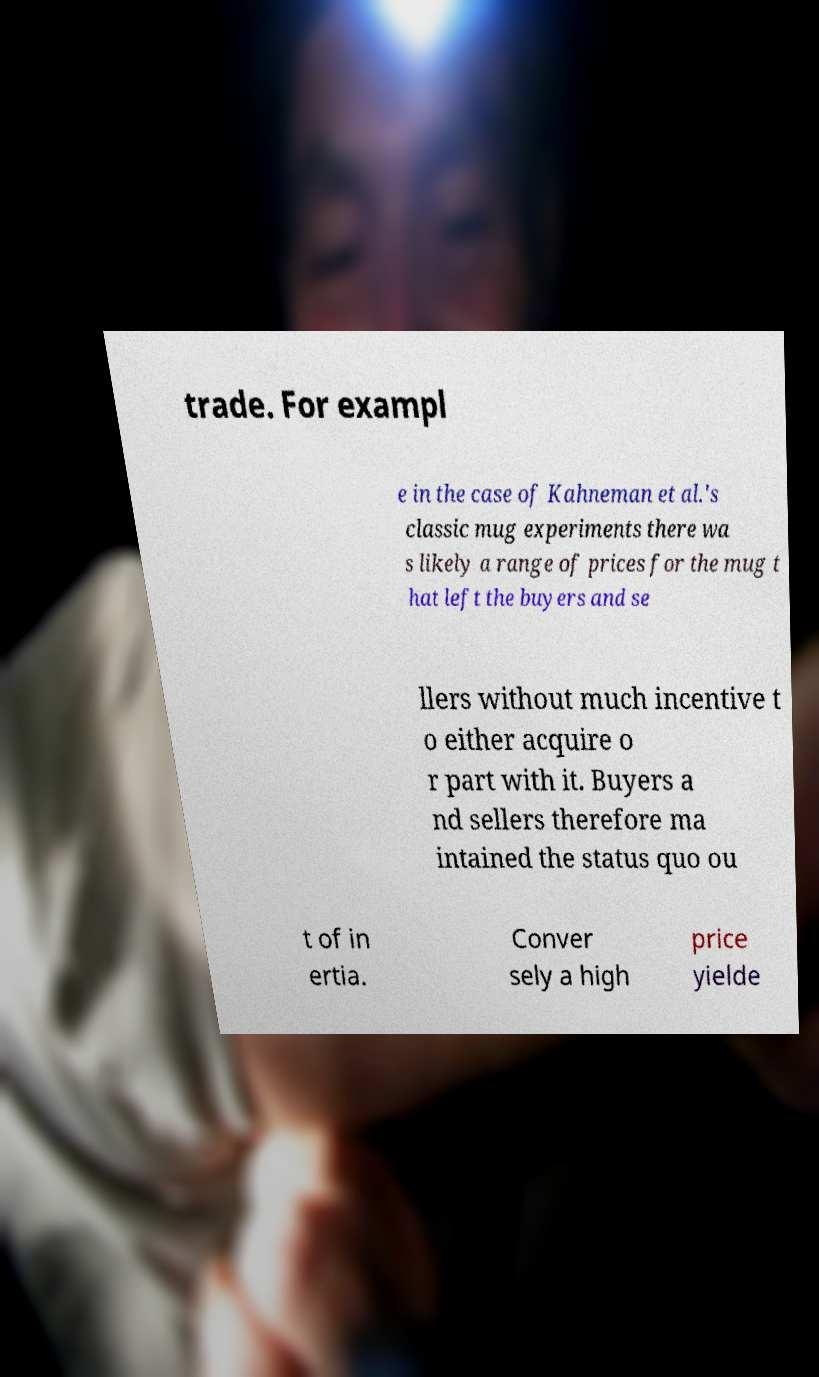What messages or text are displayed in this image? I need them in a readable, typed format. trade. For exampl e in the case of Kahneman et al.'s classic mug experiments there wa s likely a range of prices for the mug t hat left the buyers and se llers without much incentive t o either acquire o r part with it. Buyers a nd sellers therefore ma intained the status quo ou t of in ertia. Conver sely a high price yielde 